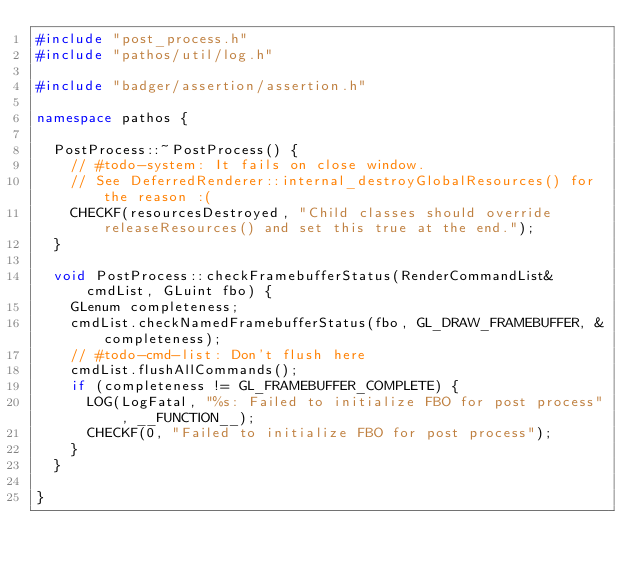<code> <loc_0><loc_0><loc_500><loc_500><_C++_>#include "post_process.h"
#include "pathos/util/log.h"

#include "badger/assertion/assertion.h"

namespace pathos {

	PostProcess::~PostProcess() {
		// #todo-system: It fails on close window.
		// See DeferredRenderer::internal_destroyGlobalResources() for the reason :(
		CHECKF(resourcesDestroyed, "Child classes should override releaseResources() and set this true at the end.");
	}

	void PostProcess::checkFramebufferStatus(RenderCommandList& cmdList, GLuint fbo) {
		GLenum completeness;
		cmdList.checkNamedFramebufferStatus(fbo, GL_DRAW_FRAMEBUFFER, &completeness);
		// #todo-cmd-list: Don't flush here
		cmdList.flushAllCommands();
		if (completeness != GL_FRAMEBUFFER_COMPLETE) {
			LOG(LogFatal, "%s: Failed to initialize FBO for post process", __FUNCTION__);
			CHECKF(0, "Failed to initialize FBO for post process");
		}
	}

}
</code> 